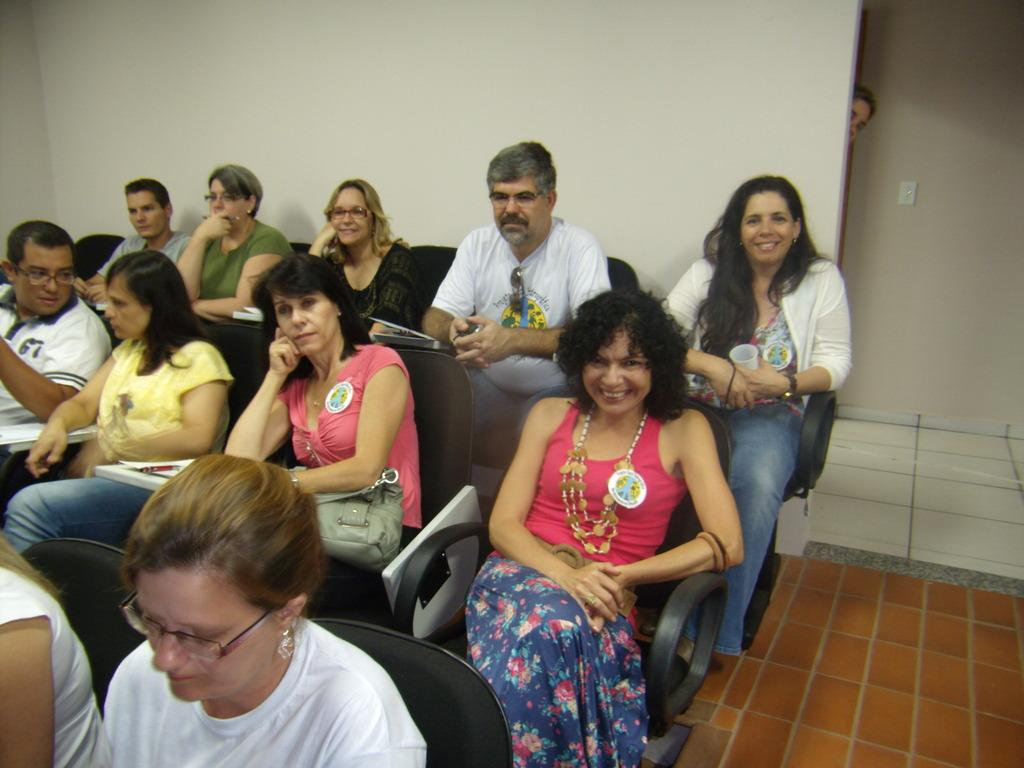What are the people in the image doing? The people in the image are sitting on chairs. What are the people holding in their hands? The people are holding objects in their hands. What can be seen in the background of the image? Walls and a person are visible in the background of the image. What other objects can be seen in the background of the image? There are other objects present in the background of the image. What type of corn is being grown in the image? There is no corn present in the image. How many boots can be seen in the image? There are no boots present in the image. 